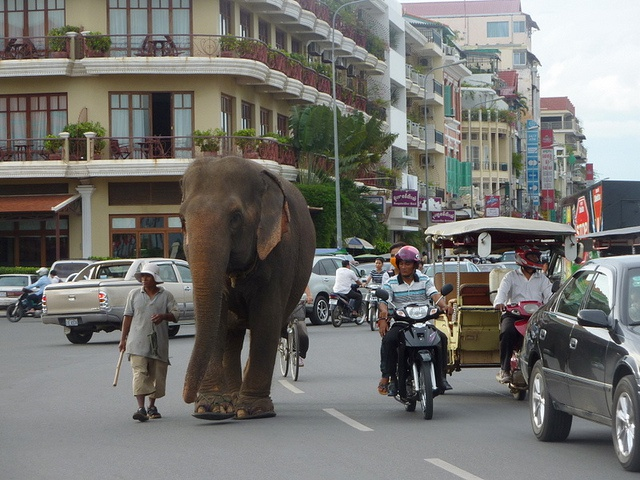Describe the objects in this image and their specific colors. I can see elephant in gray, black, and maroon tones, car in gray, black, darkgray, and lightgray tones, truck in gray, darkgray, black, and lightgray tones, people in gray, black, and darkgray tones, and motorcycle in gray, black, darkgray, and lightgray tones in this image. 